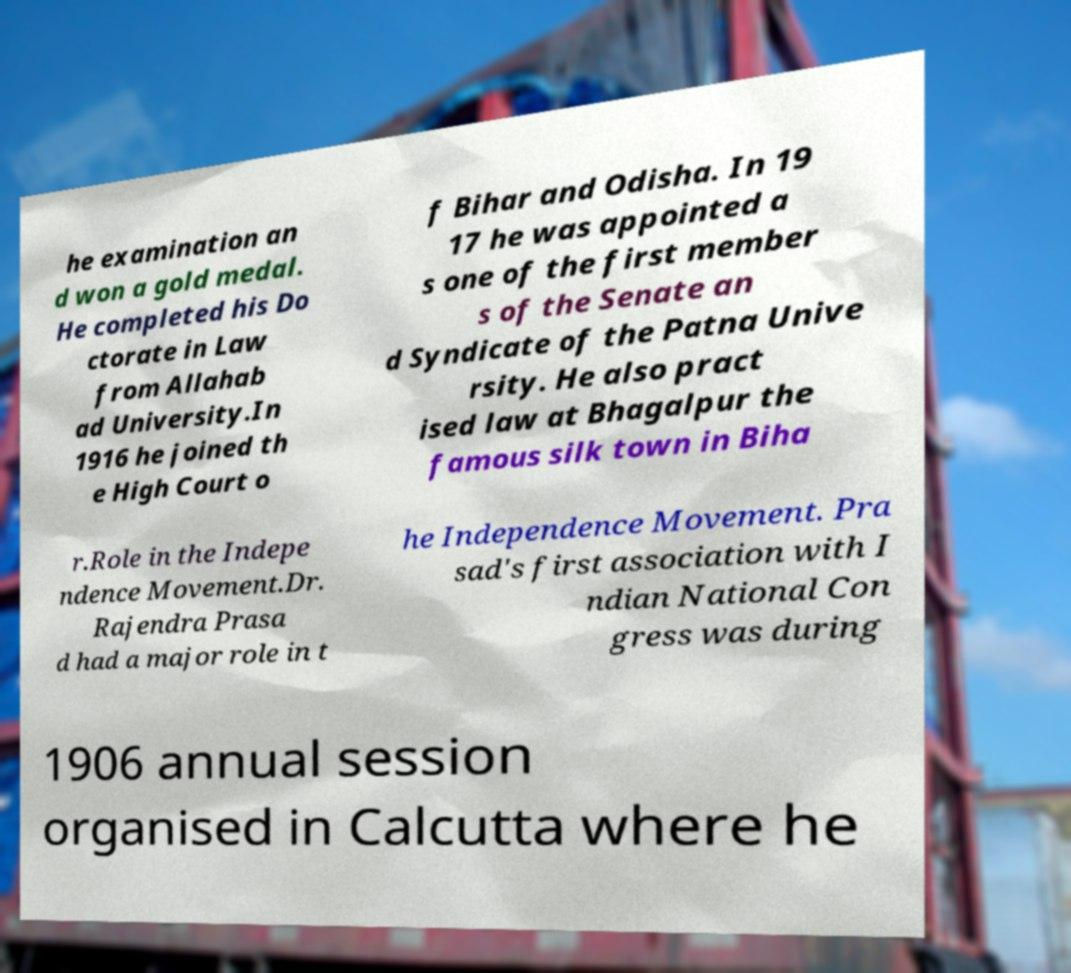Please read and relay the text visible in this image. What does it say? he examination an d won a gold medal. He completed his Do ctorate in Law from Allahab ad University.In 1916 he joined th e High Court o f Bihar and Odisha. In 19 17 he was appointed a s one of the first member s of the Senate an d Syndicate of the Patna Unive rsity. He also pract ised law at Bhagalpur the famous silk town in Biha r.Role in the Indepe ndence Movement.Dr. Rajendra Prasa d had a major role in t he Independence Movement. Pra sad's first association with I ndian National Con gress was during 1906 annual session organised in Calcutta where he 